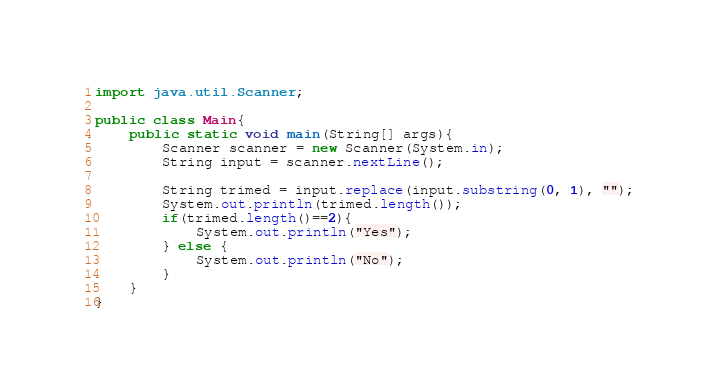Convert code to text. <code><loc_0><loc_0><loc_500><loc_500><_Java_>import java.util.Scanner;

public class Main{
	public static void main(String[] args){
		Scanner scanner = new Scanner(System.in);
		String input = scanner.nextLine();
		
		String trimed = input.replace(input.substring(0, 1), "");
		System.out.println(trimed.length());
		if(trimed.length()==2){
			System.out.println("Yes");
		} else {
			System.out.println("No");
		}
	}
}</code> 